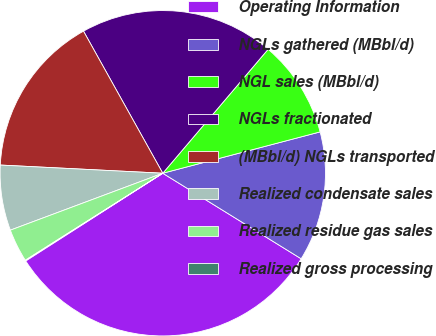Convert chart to OTSL. <chart><loc_0><loc_0><loc_500><loc_500><pie_chart><fcel>Operating Information<fcel>NGLs gathered (MBbl/d)<fcel>NGL sales (MBbl/d)<fcel>NGLs fractionated<fcel>(MBbl/d) NGLs transported<fcel>Realized condensate sales<fcel>Realized residue gas sales<fcel>Realized gross processing<nl><fcel>32.13%<fcel>12.9%<fcel>9.7%<fcel>19.31%<fcel>16.1%<fcel>6.49%<fcel>3.29%<fcel>0.08%<nl></chart> 